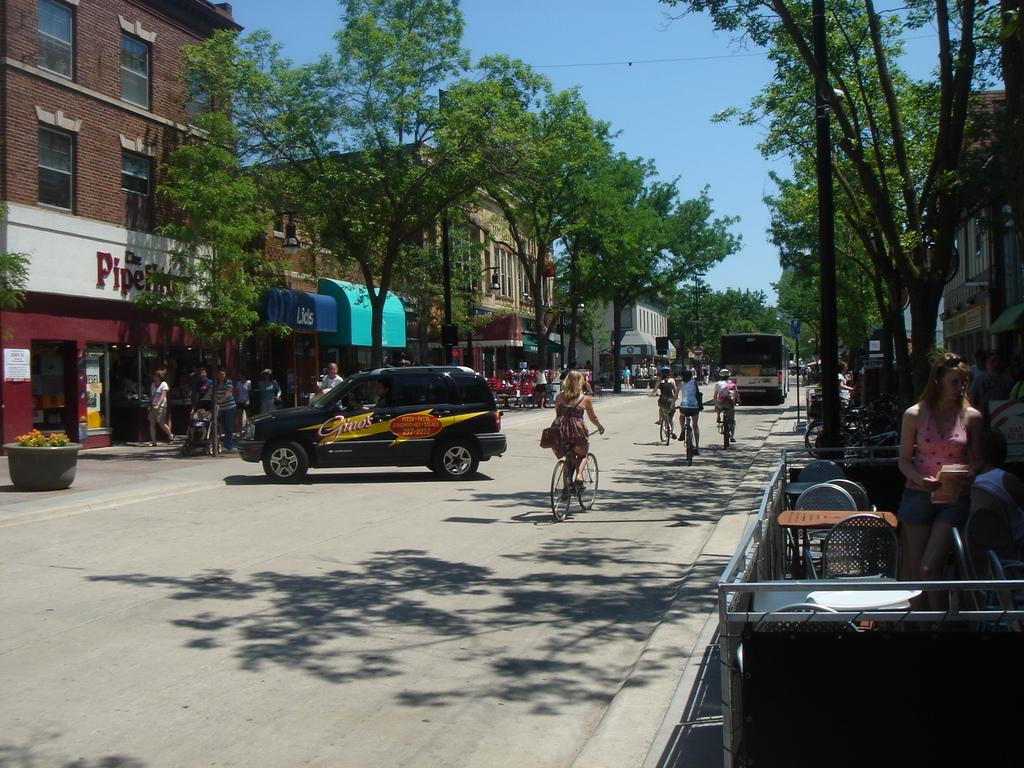What is the second word of the store on the left?
Make the answer very short. Unanswerable. What is the first word on the sign?
Offer a very short reply. Pipe. 